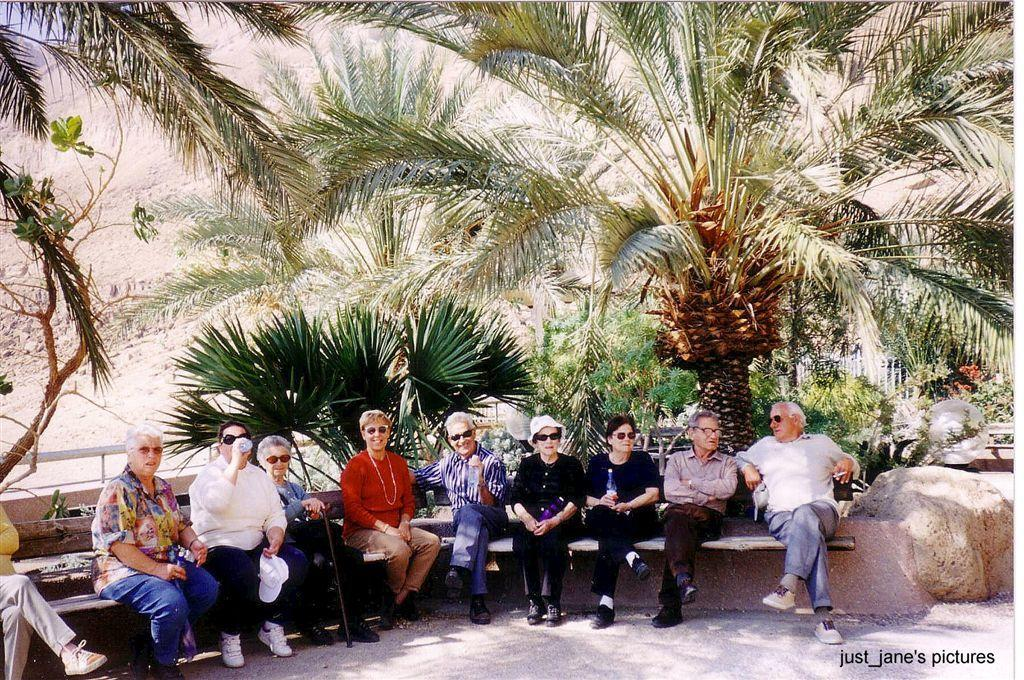What are the people in the image doing? The people in the image are sitting on a bench. Where is the bench located in relation to other objects in the image? The bench is near rocks. What can be seen behind the people in the image? Plants are visible behind the people. What type of vegetation is present in the image? There are trees in the image. What type of flight can be seen in the image? There is no flight visible in the image; it features people sitting on a bench near rocks with plants and trees in the background. 